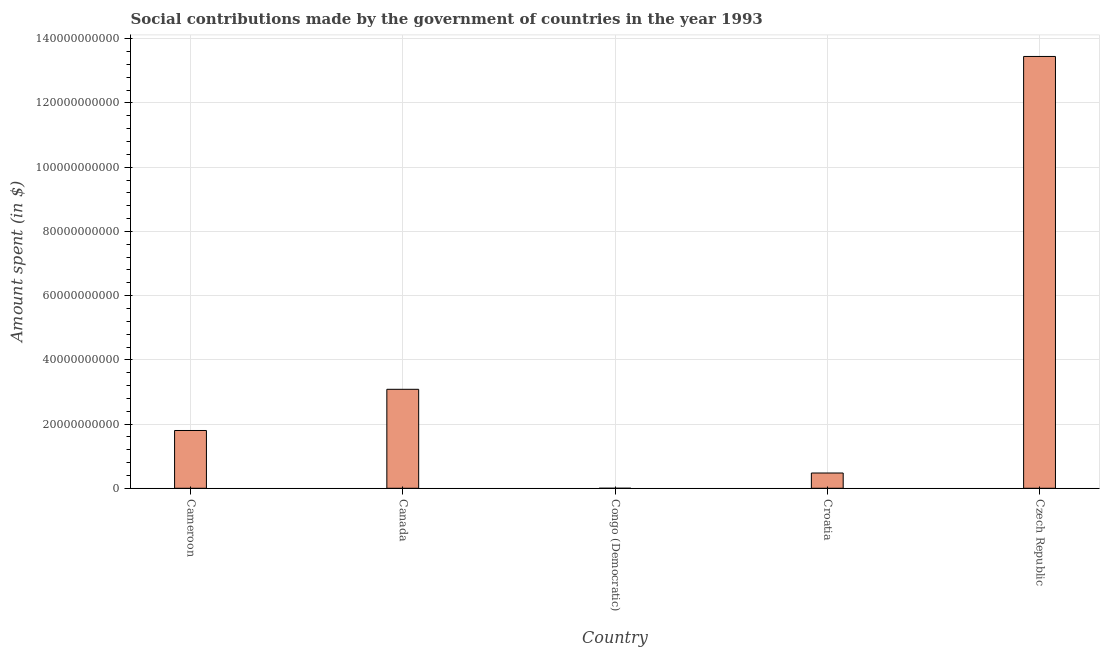Does the graph contain any zero values?
Offer a terse response. No. Does the graph contain grids?
Your response must be concise. Yes. What is the title of the graph?
Your response must be concise. Social contributions made by the government of countries in the year 1993. What is the label or title of the Y-axis?
Provide a succinct answer. Amount spent (in $). What is the amount spent in making social contributions in Congo (Democratic)?
Offer a very short reply. 170. Across all countries, what is the maximum amount spent in making social contributions?
Provide a short and direct response. 1.34e+11. Across all countries, what is the minimum amount spent in making social contributions?
Your answer should be compact. 170. In which country was the amount spent in making social contributions maximum?
Offer a terse response. Czech Republic. In which country was the amount spent in making social contributions minimum?
Give a very brief answer. Congo (Democratic). What is the sum of the amount spent in making social contributions?
Provide a succinct answer. 1.88e+11. What is the difference between the amount spent in making social contributions in Canada and Croatia?
Offer a terse response. 2.61e+1. What is the average amount spent in making social contributions per country?
Your answer should be very brief. 3.76e+1. What is the median amount spent in making social contributions?
Your response must be concise. 1.80e+1. In how many countries, is the amount spent in making social contributions greater than 60000000000 $?
Provide a short and direct response. 1. What is the ratio of the amount spent in making social contributions in Canada to that in Czech Republic?
Offer a very short reply. 0.23. Is the amount spent in making social contributions in Cameroon less than that in Congo (Democratic)?
Offer a very short reply. No. What is the difference between the highest and the second highest amount spent in making social contributions?
Keep it short and to the point. 1.04e+11. Is the sum of the amount spent in making social contributions in Cameroon and Czech Republic greater than the maximum amount spent in making social contributions across all countries?
Offer a terse response. Yes. What is the difference between the highest and the lowest amount spent in making social contributions?
Offer a very short reply. 1.34e+11. How many bars are there?
Give a very brief answer. 5. How many countries are there in the graph?
Offer a very short reply. 5. What is the Amount spent (in $) in Cameroon?
Keep it short and to the point. 1.80e+1. What is the Amount spent (in $) in Canada?
Your answer should be very brief. 3.08e+1. What is the Amount spent (in $) in Congo (Democratic)?
Provide a short and direct response. 170. What is the Amount spent (in $) of Croatia?
Keep it short and to the point. 4.76e+09. What is the Amount spent (in $) of Czech Republic?
Your response must be concise. 1.34e+11. What is the difference between the Amount spent (in $) in Cameroon and Canada?
Offer a terse response. -1.28e+1. What is the difference between the Amount spent (in $) in Cameroon and Congo (Democratic)?
Your answer should be compact. 1.80e+1. What is the difference between the Amount spent (in $) in Cameroon and Croatia?
Keep it short and to the point. 1.32e+1. What is the difference between the Amount spent (in $) in Cameroon and Czech Republic?
Your answer should be compact. -1.16e+11. What is the difference between the Amount spent (in $) in Canada and Congo (Democratic)?
Your response must be concise. 3.08e+1. What is the difference between the Amount spent (in $) in Canada and Croatia?
Your response must be concise. 2.61e+1. What is the difference between the Amount spent (in $) in Canada and Czech Republic?
Your answer should be very brief. -1.04e+11. What is the difference between the Amount spent (in $) in Congo (Democratic) and Croatia?
Ensure brevity in your answer.  -4.76e+09. What is the difference between the Amount spent (in $) in Congo (Democratic) and Czech Republic?
Give a very brief answer. -1.34e+11. What is the difference between the Amount spent (in $) in Croatia and Czech Republic?
Make the answer very short. -1.30e+11. What is the ratio of the Amount spent (in $) in Cameroon to that in Canada?
Keep it short and to the point. 0.58. What is the ratio of the Amount spent (in $) in Cameroon to that in Congo (Democratic)?
Provide a succinct answer. 1.06e+08. What is the ratio of the Amount spent (in $) in Cameroon to that in Croatia?
Give a very brief answer. 3.78. What is the ratio of the Amount spent (in $) in Cameroon to that in Czech Republic?
Your response must be concise. 0.13. What is the ratio of the Amount spent (in $) in Canada to that in Congo (Democratic)?
Provide a short and direct response. 1.81e+08. What is the ratio of the Amount spent (in $) in Canada to that in Croatia?
Make the answer very short. 6.48. What is the ratio of the Amount spent (in $) in Canada to that in Czech Republic?
Your answer should be compact. 0.23. What is the ratio of the Amount spent (in $) in Croatia to that in Czech Republic?
Give a very brief answer. 0.04. 